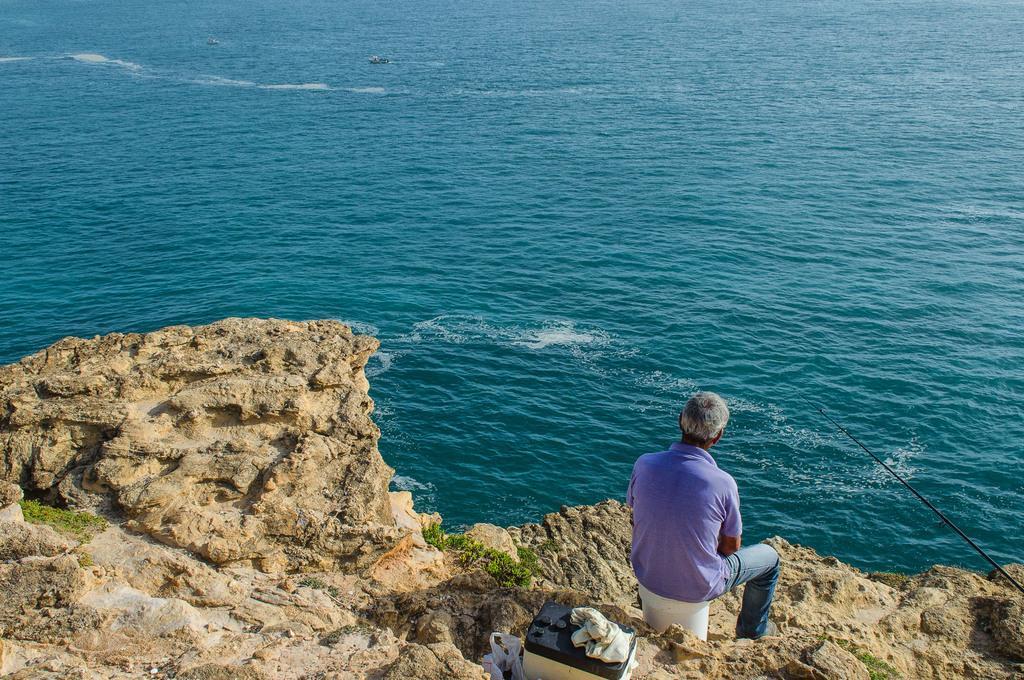Please provide a concise description of this image. This image is taken outdoors. At the top of the image there is a sea. At the bottom of the image there are many rocks and there is an object on the rock. In the middle of the image a man is sitting on the bucket. On the right side of the image there is a fishing rope. 